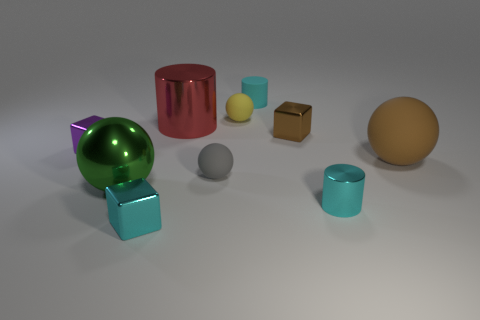Subtract all cubes. How many objects are left? 7 Add 6 brown metallic cubes. How many brown metallic cubes are left? 7 Add 9 gray metal things. How many gray metal things exist? 9 Subtract 0 yellow cubes. How many objects are left? 10 Subtract all red spheres. Subtract all tiny gray spheres. How many objects are left? 9 